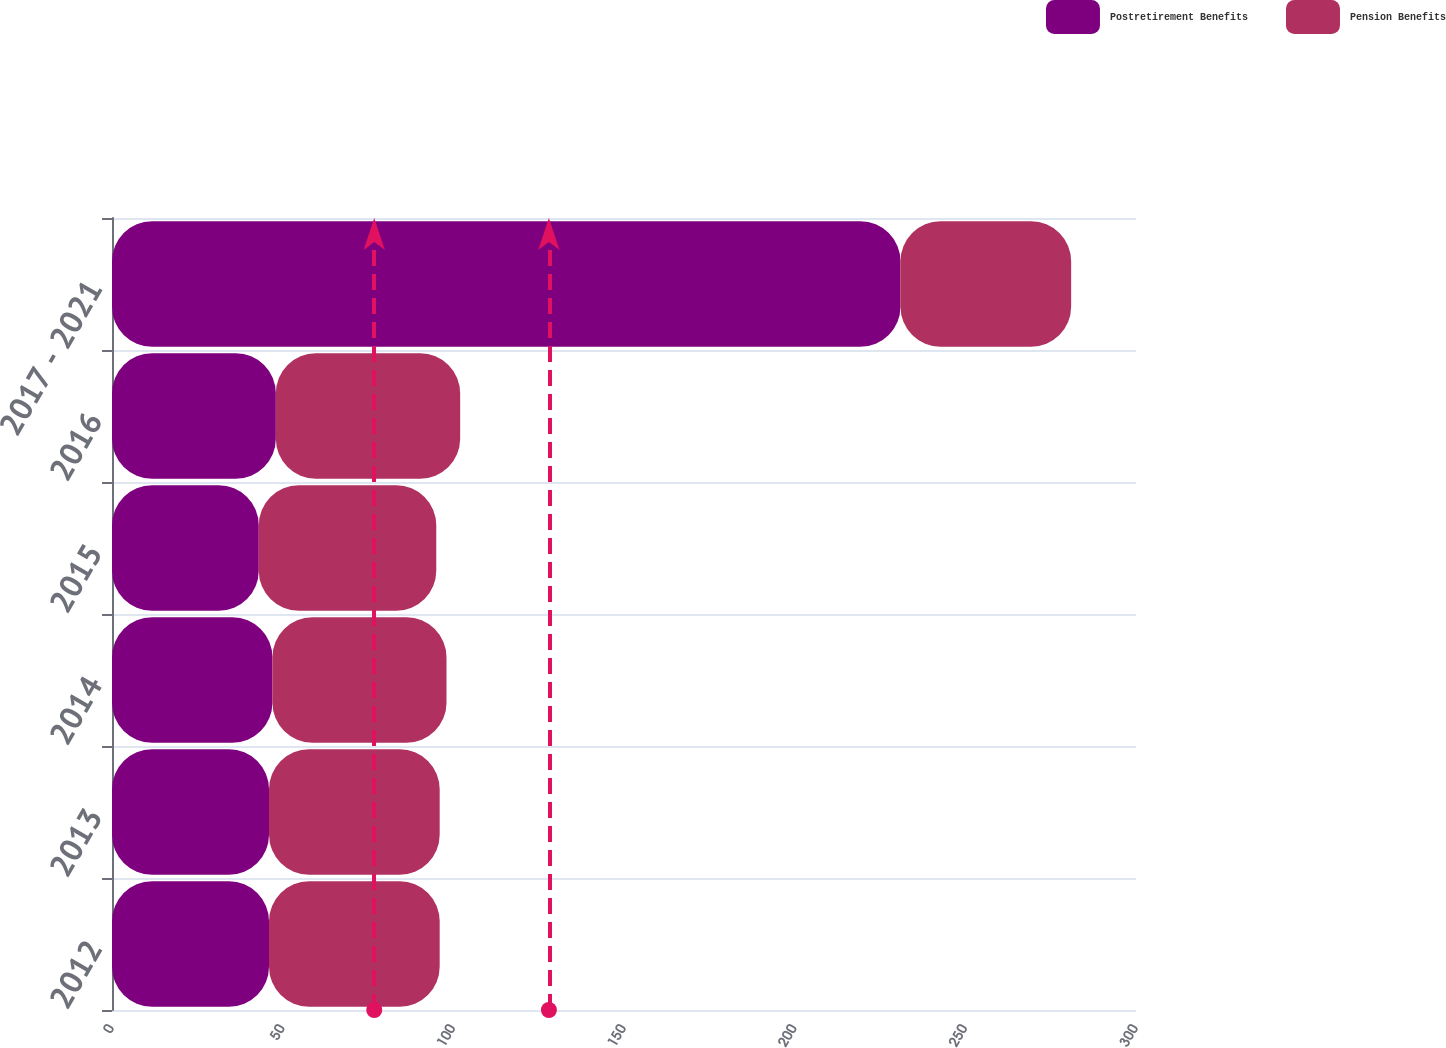Convert chart. <chart><loc_0><loc_0><loc_500><loc_500><stacked_bar_chart><ecel><fcel>2012<fcel>2013<fcel>2014<fcel>2015<fcel>2016<fcel>2017 - 2021<nl><fcel>Postretirement Benefits<fcel>46<fcel>46<fcel>47<fcel>43<fcel>48<fcel>231<nl><fcel>Pension Benefits<fcel>50<fcel>50<fcel>51<fcel>52<fcel>54<fcel>50<nl></chart> 